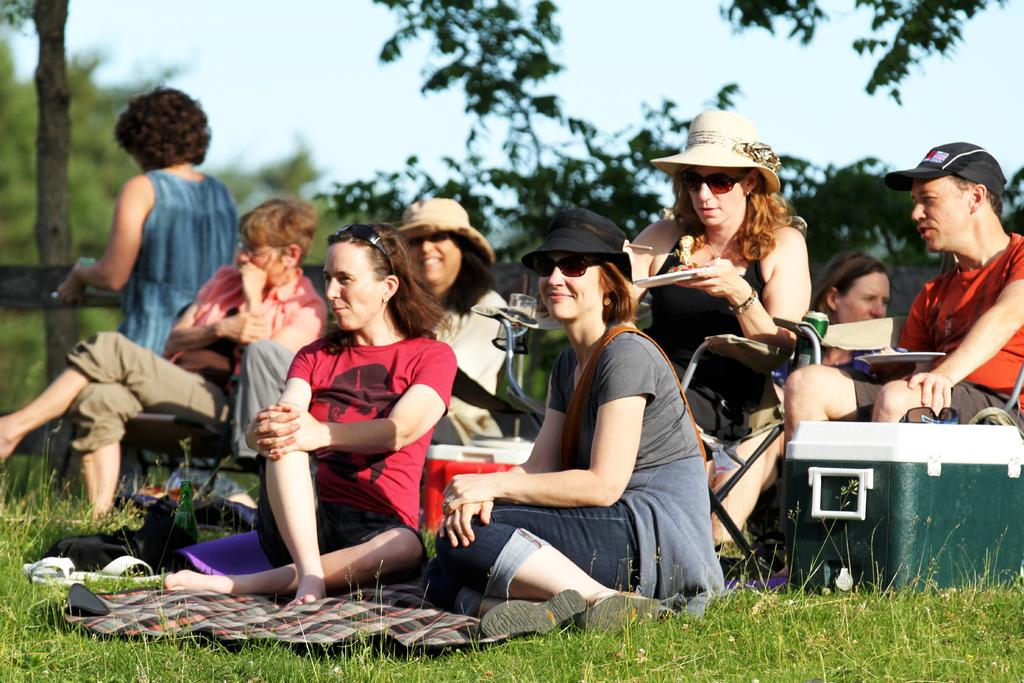How many people are in the image? There is a group of people in the image, but the exact number is not specified. What are the people doing in the image? The people are sitting in various positions and on different objects. What objects are the people sitting on? Some people are sitting on chairs, a cloth, a box, a bottle, and the grass. What can be seen in the background of the image? There are trees and the sky visible in the background of the image. What type of office furniture can be seen in the image? There is no office furniture present in the image. What kind of cloud formation is visible in the sky? The image does not provide enough detail to describe any specific cloud formations in the sky. 